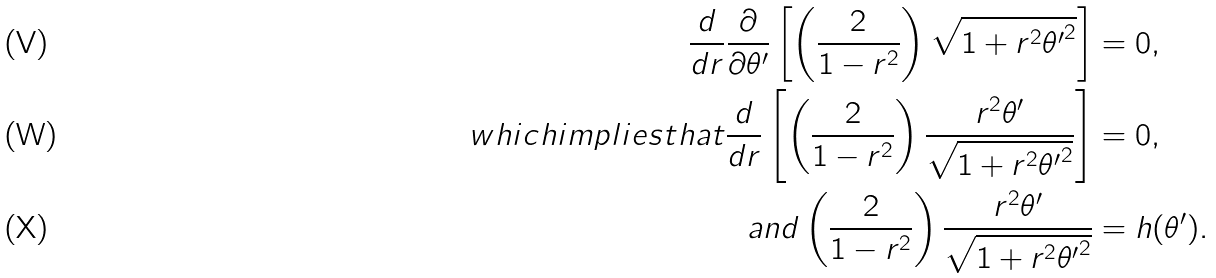<formula> <loc_0><loc_0><loc_500><loc_500>\frac { d } { d r } \frac { \partial } { \partial \theta ^ { \prime } } \left [ \left ( \frac { 2 } { 1 - r ^ { 2 } } \right ) \sqrt { 1 + r ^ { 2 } { \theta ^ { \prime } } ^ { 2 } } \right ] & = 0 , \\ { w h i c h i m p l i e s t h a t } \frac { d } { d r } \left [ \left ( \frac { 2 } { 1 - r ^ { 2 } } \right ) \frac { r ^ { 2 } \theta ^ { \prime } } { \sqrt { 1 + r ^ { 2 } { \theta ^ { \prime } } ^ { 2 } } } \right ] & = 0 , \\ { a n d } \left ( \frac { 2 } { 1 - r ^ { 2 } } \right ) \frac { r ^ { 2 } \theta ^ { \prime } } { \sqrt { 1 + r ^ { 2 } { \theta ^ { \prime } } ^ { 2 } } } & = h ( \theta ^ { \prime } ) .</formula> 